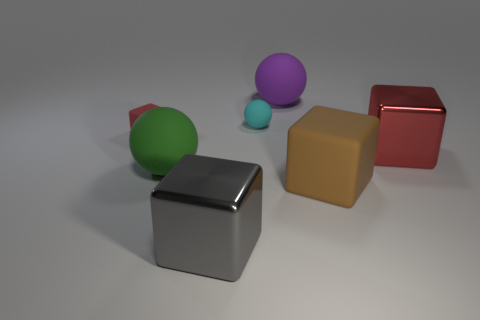Subtract all tiny cyan spheres. How many spheres are left? 2 Add 2 big cyan cylinders. How many objects exist? 9 Subtract all purple spheres. How many spheres are left? 2 Subtract 0 red cylinders. How many objects are left? 7 Subtract all spheres. How many objects are left? 4 Subtract 2 cubes. How many cubes are left? 2 Subtract all cyan spheres. Subtract all brown cylinders. How many spheres are left? 2 Subtract all green cylinders. How many brown blocks are left? 1 Subtract all tiny gray metallic cylinders. Subtract all large red cubes. How many objects are left? 6 Add 7 small red matte blocks. How many small red matte blocks are left? 8 